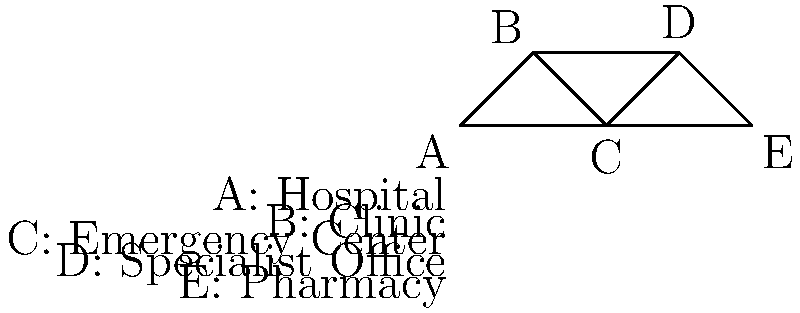In the healthcare provider network shown above, what is the minimum number of connections that need to be removed to completely disconnect the pharmacy (E) from the hospital (A)? To solve this problem, we need to analyze the connectivity between nodes A (Hospital) and E (Pharmacy) in the network. Let's follow these steps:

1. Identify all possible paths from A to E:
   - Path 1: A → B → C → D → E
   - Path 2: A → B → C → E
   - Path 3: A → C → D → E
   - Path 4: A → C → E

2. Determine the minimum number of connections to remove:
   - We need to cut all paths simultaneously.
   - Removing the connection C-E would cut paths 2 and 4.
   - We still need to cut either A-C or C-D to disconnect the remaining paths.

3. Conclusion:
   - The minimum number of connections to remove is 2.
   - We can remove C-E and either A-C or C-D to completely disconnect A from E.

This analysis demonstrates the concept of edge connectivity in graph theory, which is crucial for understanding the robustness of healthcare networks and identifying potential weak points in the system.
Answer: 2 connections 